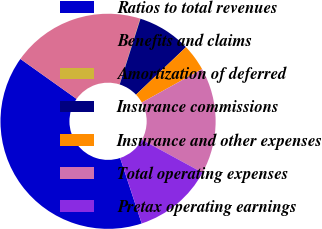<chart> <loc_0><loc_0><loc_500><loc_500><pie_chart><fcel>Ratios to total revenues<fcel>Benefits and claims<fcel>Amortization of deferred<fcel>Insurance commissions<fcel>Insurance and other expenses<fcel>Total operating expenses<fcel>Pretax operating earnings<nl><fcel>39.9%<fcel>19.98%<fcel>0.05%<fcel>8.02%<fcel>4.04%<fcel>15.99%<fcel>12.01%<nl></chart> 